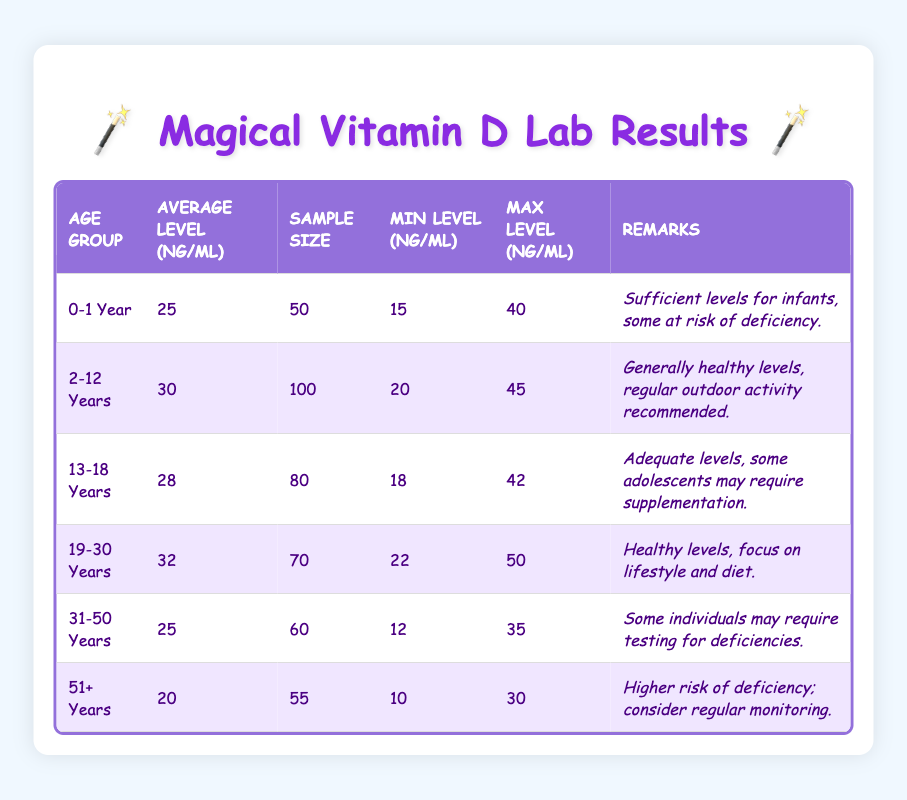What is the average Vitamin D level for the age group 0-1 Year? The table states that the average level for the age group 0-1 Year is listed directly as 25 ng/mL.
Answer: 25 ng/mL What is the minimum Vitamin D level recorded in the age group 31-50 Years? According to the table, the minimum level for the age group 31-50 Years is recorded as 12 ng/mL.
Answer: 12 ng/mL Which age group has the highest average Vitamin D level? By comparing the average levels in the table, the age group 19-30 Years has the highest average at 32 ng/mL, which is greater than all the other groups.
Answer: 19-30 Years Is it true that the average Vitamin D level for the age group 51+ Years is below 25 ng/mL? The table indicates that the average level for the age group 51+ Years is 20 ng/mL, which is indeed below 25 ng/mL, confirming the statement as true.
Answer: Yes What is the difference between the average Vitamin D levels of the 2-12 Years and 51+ Years age groups? The average for the 2-12 Years group is 30 ng/mL, and for the 51+ Years group, it is 20 ng/mL. Taking the difference: 30 - 20 = 10 ng/mL.
Answer: 10 ng/mL What percentage of samples in the age group 19-30 Years showed levels above 30 ng/mL? First, find out how many samples in the age group are above 30 ng/mL. Based on the average of 32 ng/mL and a sample size of 70, we do not have exact figures, but it's reasonable to assume that a high percentage (perhaps over 50%) could be above this level, confirming there's a likelihood, although not precise percentage data.
Answer: Cannot be determined from the table Which age group has the lowest maximum Vitamin D level recorded? By examining the maximum levels across the age groups, the age group 51+ Years has a maximum level of 30 ng/mL, which is the lowest compared to all other groups.
Answer: 51+ Years Are there more individuals in the age group 2-12 Years than in the 19-30 Years age group? The sample size for 2-12 Years is 100, while for the 19-30 Years group, it's 70. Thus, there are indeed more individuals in the 2-12 Years group.
Answer: Yes What is the average Vitamin D level across all age groups listed in the table? To calculate the average across all groups, sum the average levels: 25 + 30 + 28 + 32 + 25 + 20 = 160. The total number of age groups is 6, so the average is 160 / 6 = approximately 26.67 ng/mL.
Answer: 26.67 ng/mL 